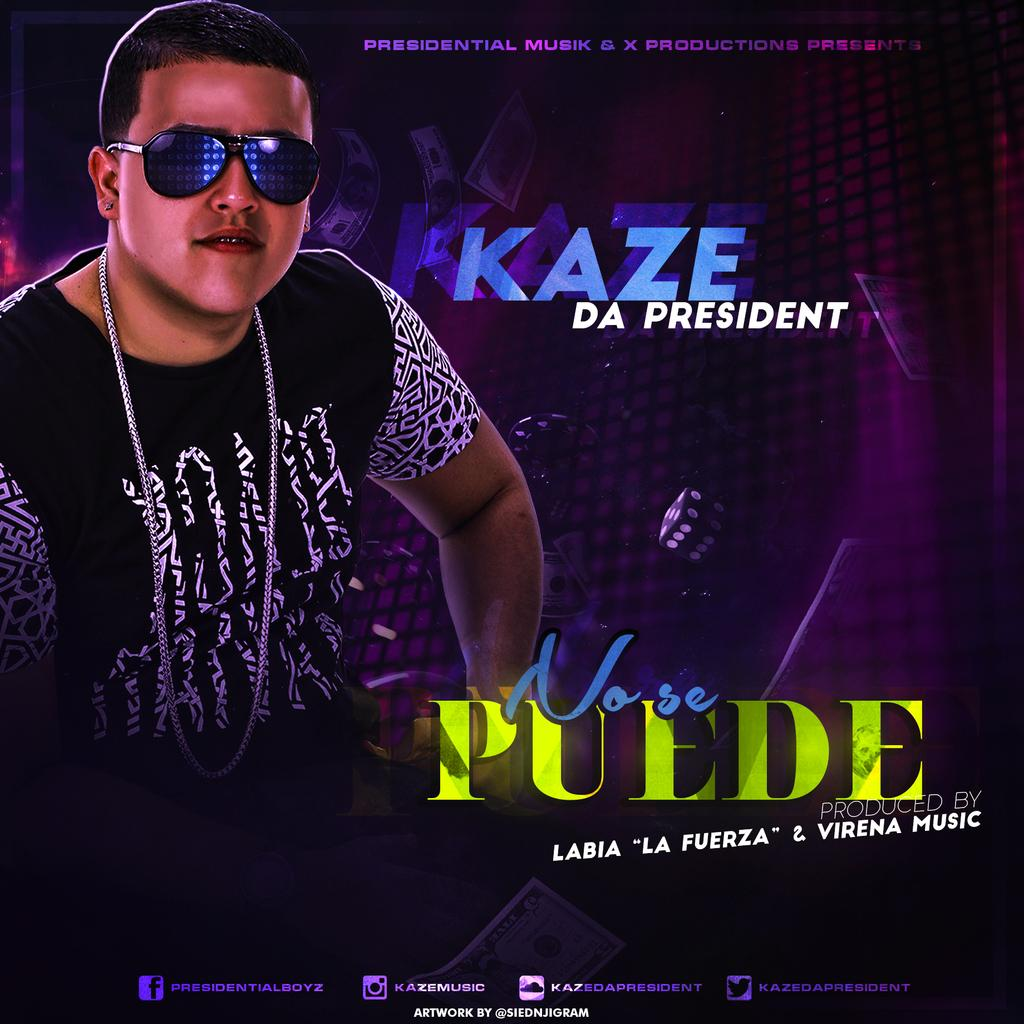What is the main subject of the poster in the image? The poster features a man wearing glasses. What else can be seen on the poster besides the man? There is text on the poster. What type of mitten is the man wearing in the image? The man in the poster is not wearing a mitten; he is wearing glasses. How does the mother in the image relate to the poster? There is no mention of a mother in the image or the poster. 